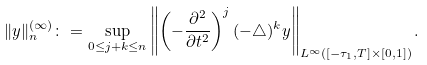Convert formula to latex. <formula><loc_0><loc_0><loc_500><loc_500>& \| y \| _ { n } ^ { ( \infty ) } \colon = \sup _ { 0 \leq j + k \leq n } \left \| \left ( - \frac { \partial ^ { 2 } } { \partial t ^ { 2 } } \right ) ^ { j } ( - \triangle ) ^ { k } y \right \| _ { L ^ { \infty } ( [ - \tau _ { 1 } , T ] \times [ 0 , 1 ] ) } .</formula> 